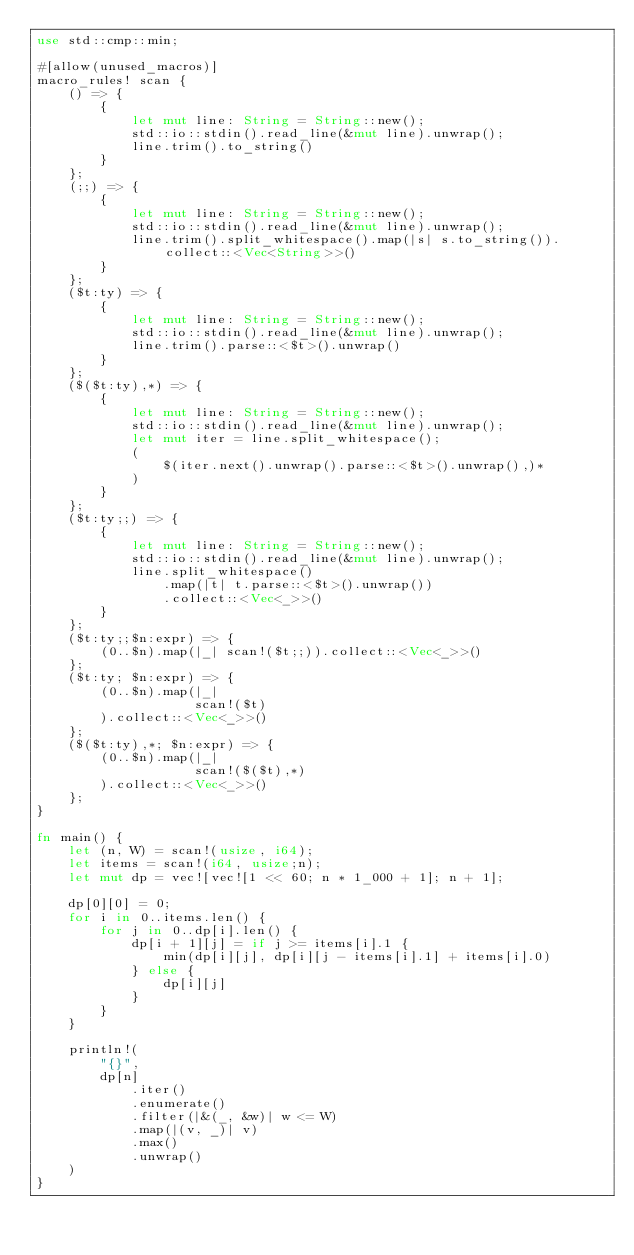<code> <loc_0><loc_0><loc_500><loc_500><_Rust_>use std::cmp::min;

#[allow(unused_macros)]
macro_rules! scan {
    () => {
        {
            let mut line: String = String::new();
            std::io::stdin().read_line(&mut line).unwrap();
            line.trim().to_string()
        }
    };
    (;;) => {
        {
            let mut line: String = String::new();
            std::io::stdin().read_line(&mut line).unwrap();
            line.trim().split_whitespace().map(|s| s.to_string()).collect::<Vec<String>>()
        }
    };
    ($t:ty) => {
        {
            let mut line: String = String::new();
            std::io::stdin().read_line(&mut line).unwrap();
            line.trim().parse::<$t>().unwrap()
        }
    };
    ($($t:ty),*) => {
        {
            let mut line: String = String::new();
            std::io::stdin().read_line(&mut line).unwrap();
            let mut iter = line.split_whitespace();
            (
                $(iter.next().unwrap().parse::<$t>().unwrap(),)*
            )
        }
    };
    ($t:ty;;) => {
        {
            let mut line: String = String::new();
            std::io::stdin().read_line(&mut line).unwrap();
            line.split_whitespace()
                .map(|t| t.parse::<$t>().unwrap())
                .collect::<Vec<_>>()
        }
    };
    ($t:ty;;$n:expr) => {
        (0..$n).map(|_| scan!($t;;)).collect::<Vec<_>>()
    };
    ($t:ty; $n:expr) => {
        (0..$n).map(|_|
                    scan!($t)
        ).collect::<Vec<_>>()
    };
    ($($t:ty),*; $n:expr) => {
        (0..$n).map(|_|
                    scan!($($t),*)
        ).collect::<Vec<_>>()
    };
}

fn main() {
    let (n, W) = scan!(usize, i64);
    let items = scan!(i64, usize;n);
    let mut dp = vec![vec![1 << 60; n * 1_000 + 1]; n + 1];

    dp[0][0] = 0;
    for i in 0..items.len() {
        for j in 0..dp[i].len() {
            dp[i + 1][j] = if j >= items[i].1 {
                min(dp[i][j], dp[i][j - items[i].1] + items[i].0)
            } else {
                dp[i][j]
            }
        }
    }

    println!(
        "{}",
        dp[n]
            .iter()
            .enumerate()
            .filter(|&(_, &w)| w <= W)
            .map(|(v, _)| v)
            .max()
            .unwrap()
    )
}
</code> 